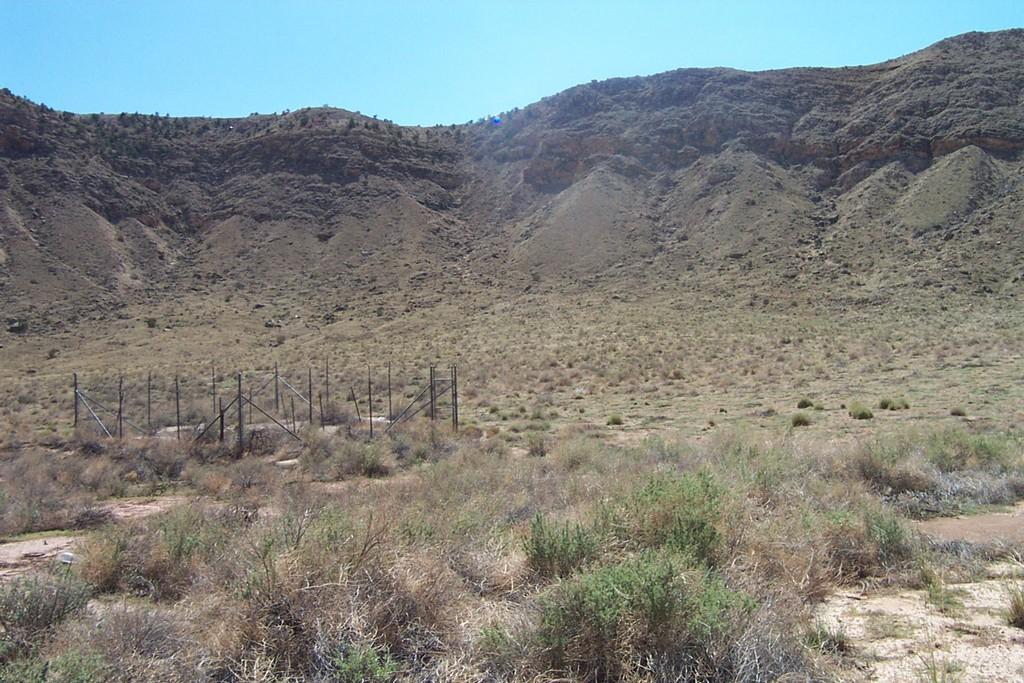Please provide a concise description of this image. In this image there are hills. At the bottom there is grass and a fence. 